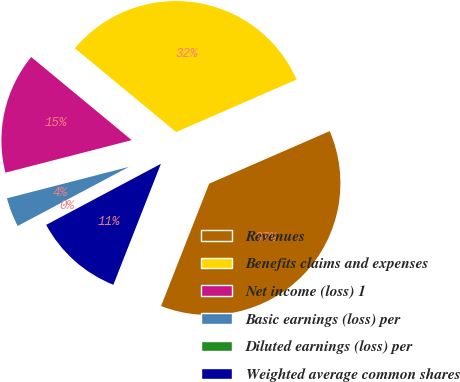<chart> <loc_0><loc_0><loc_500><loc_500><pie_chart><fcel>Revenues<fcel>Benefits claims and expenses<fcel>Net income (loss) 1<fcel>Basic earnings (loss) per<fcel>Diluted earnings (loss) per<fcel>Weighted average common shares<nl><fcel>37.5%<fcel>32.46%<fcel>15.01%<fcel>3.76%<fcel>0.01%<fcel>11.26%<nl></chart> 